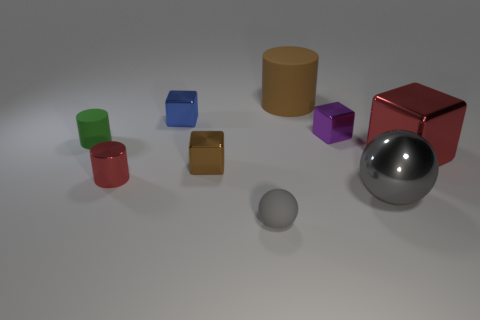Are there any other things of the same color as the small metallic cylinder?
Offer a very short reply. Yes. What is the shape of the green object that is the same material as the big brown thing?
Ensure brevity in your answer.  Cylinder. There is a tiny block that is behind the large red cube and left of the purple metal cube; what material is it made of?
Your response must be concise. Metal. Is there anything else that is the same size as the green matte thing?
Provide a succinct answer. Yes. Does the tiny rubber sphere have the same color as the large metallic ball?
Ensure brevity in your answer.  Yes. There is a small thing that is the same color as the big cylinder; what shape is it?
Provide a succinct answer. Cube. What number of other shiny things have the same shape as the purple shiny thing?
Give a very brief answer. 3. The brown thing that is the same material as the large gray sphere is what size?
Make the answer very short. Small. Do the red metal cube and the purple object have the same size?
Give a very brief answer. No. Is there a tiny matte sphere?
Provide a short and direct response. Yes. 